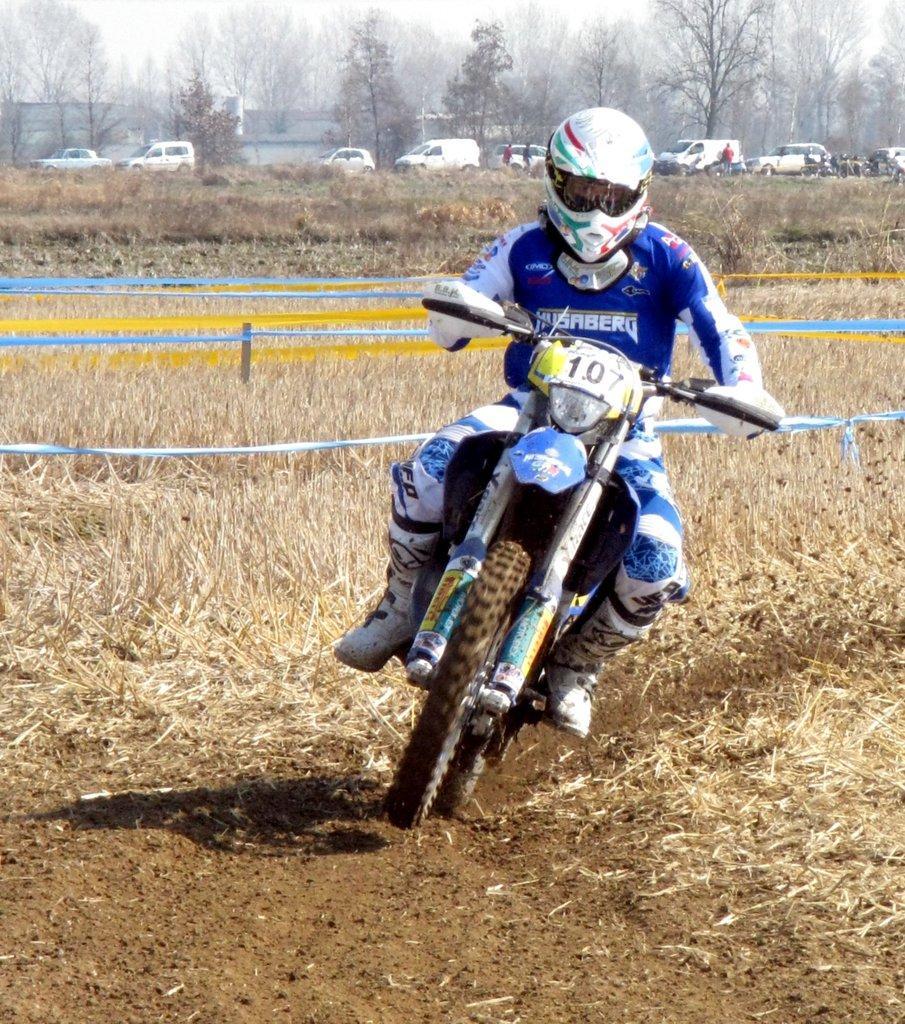Could you give a brief overview of what you see in this image? In this image we can see a person riding a motorbike. We can also some grass, poles tied with ribbons, a group of trees, a group of vehicles and some people on the ground. We can also see a group of trees and the sky which looks cloudy. 